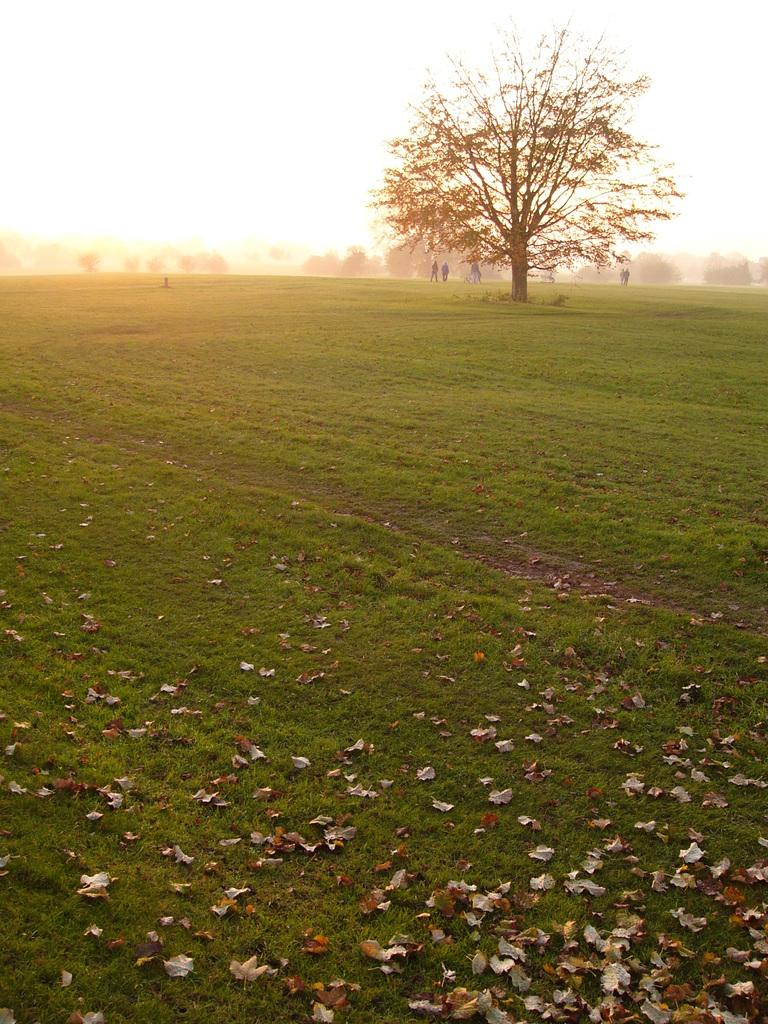What type of natural elements can be seen in the image? There are trees in the image. Are there any human elements present in the image? Yes, there are people in the image. What is covering the surface at the bottom of the image? Dried leaves and grass are present on the surface at the bottom of the image. What is visible at the top of the image? The sky is visible at the top of the image. How many steps are there in the image? There is no mention of steps in the image, so it is impossible to determine the number of steps. What type of seat can be seen in the image? There is no seat present in the image. 